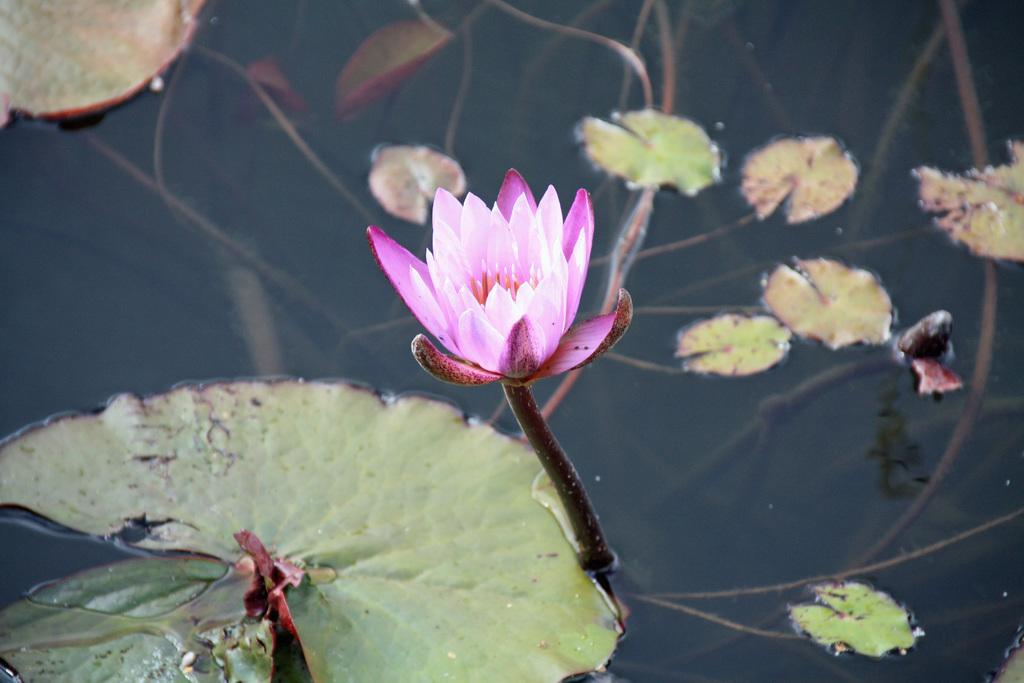What is the main feature of the image? There is a pond in the image. What can be found in the pond? There is a lotus flower and leaves in the pond. What type of plastic material can be seen floating in the pond? There is no plastic material visible in the image; the pond contains a lotus flower and leaves. 